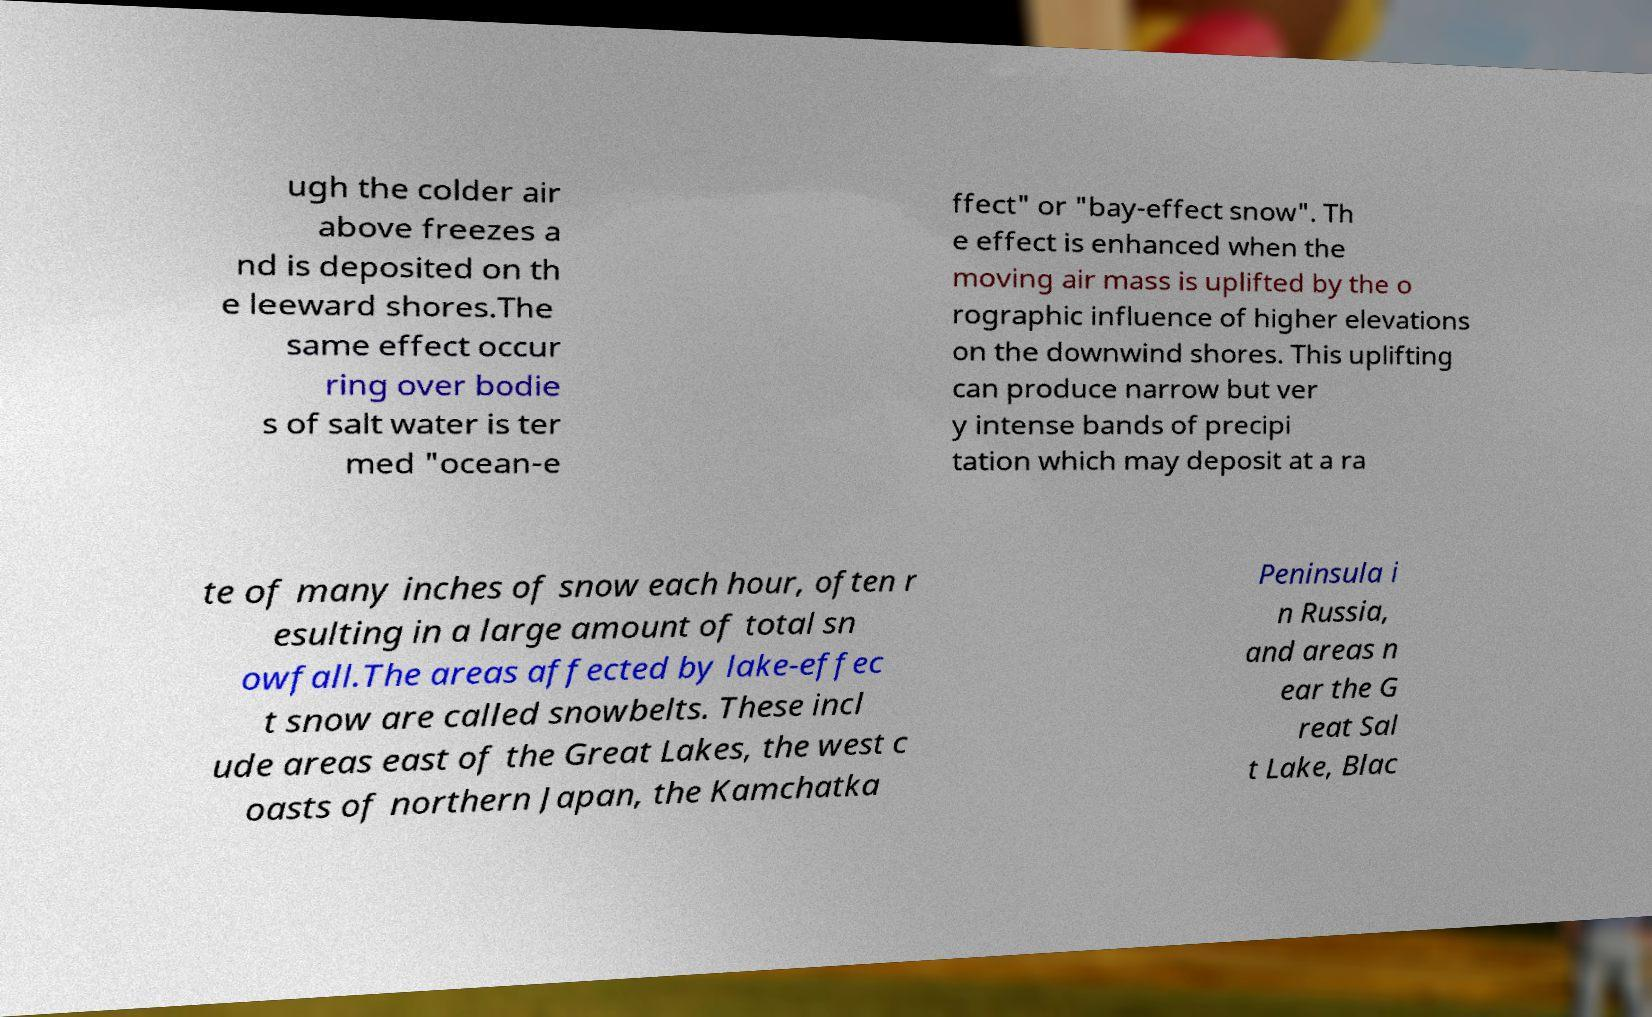Please identify and transcribe the text found in this image. ugh the colder air above freezes a nd is deposited on th e leeward shores.The same effect occur ring over bodie s of salt water is ter med "ocean-e ffect" or "bay-effect snow". Th e effect is enhanced when the moving air mass is uplifted by the o rographic influence of higher elevations on the downwind shores. This uplifting can produce narrow but ver y intense bands of precipi tation which may deposit at a ra te of many inches of snow each hour, often r esulting in a large amount of total sn owfall.The areas affected by lake-effec t snow are called snowbelts. These incl ude areas east of the Great Lakes, the west c oasts of northern Japan, the Kamchatka Peninsula i n Russia, and areas n ear the G reat Sal t Lake, Blac 